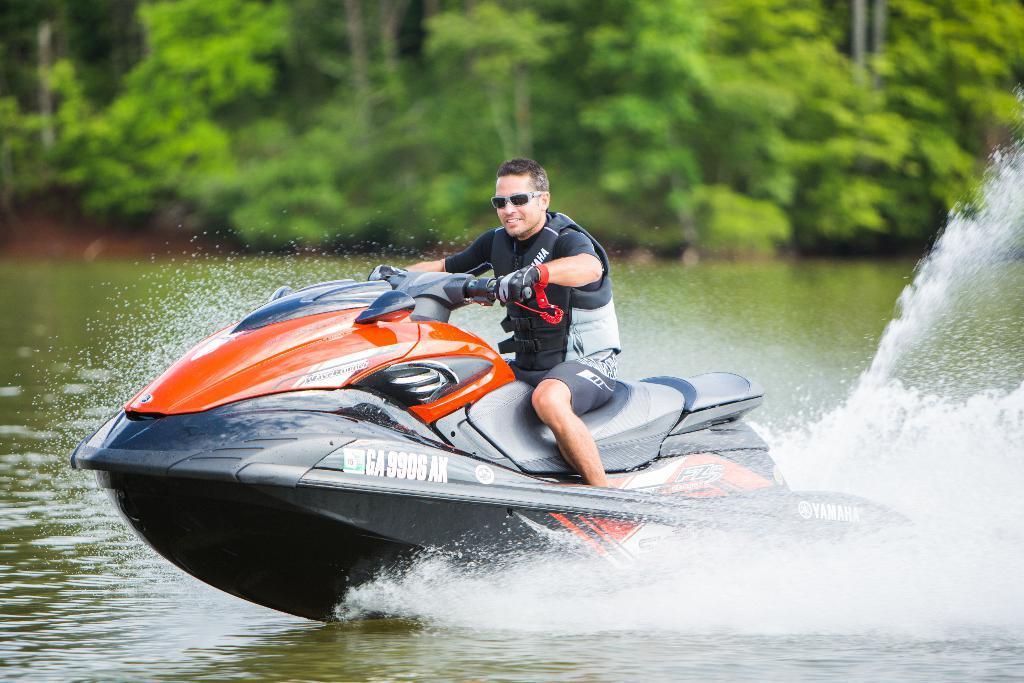How would you summarize this image in a sentence or two? In this image we can see a jet ski on the water. There is a man sitting on the jet ski. In the background there are trees. 